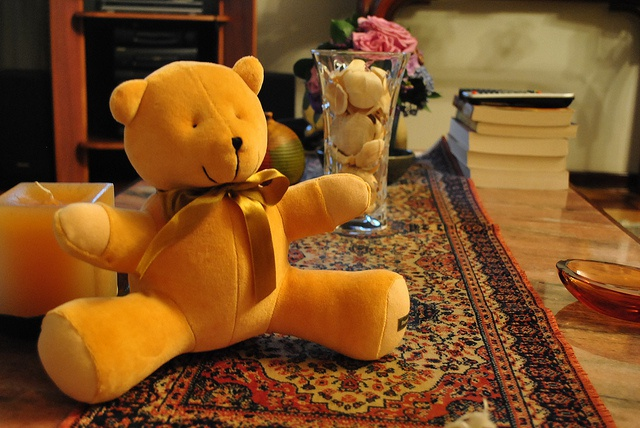Describe the objects in this image and their specific colors. I can see teddy bear in black, brown, orange, and maroon tones, dining table in black, olive, maroon, and tan tones, cup in black, olive, maroon, tan, and gray tones, vase in black, olive, maroon, tan, and gray tones, and bowl in black, maroon, and red tones in this image. 